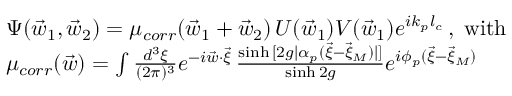<formula> <loc_0><loc_0><loc_500><loc_500>\begin{array} { r l } & { \Psi ( \vec { w } _ { 1 } , \vec { w } _ { 2 } ) = \mu _ { c o r r } ( \vec { w } _ { 1 } + \vec { w } _ { 2 } ) \, U ( \vec { w } _ { 1 } ) V ( \vec { w } _ { 1 } ) e ^ { i k _ { p } l _ { c } } \, , \, w i t h } \\ & { \mu _ { c o r r } ( \vec { w } ) = \int \frac { d ^ { 3 } \xi } { ( 2 \pi ) ^ { 3 } } e ^ { - i \vec { w } \cdot \vec { \xi } } \, \frac { \sinh { [ 2 g | { \alpha } _ { p } ( \vec { \xi } - \vec { \xi } _ { M } ) | ] } } { \sinh { 2 g } } e ^ { i \phi _ { p } ( \vec { \xi } - \vec { \xi } _ { M } ) } } \end{array}</formula> 